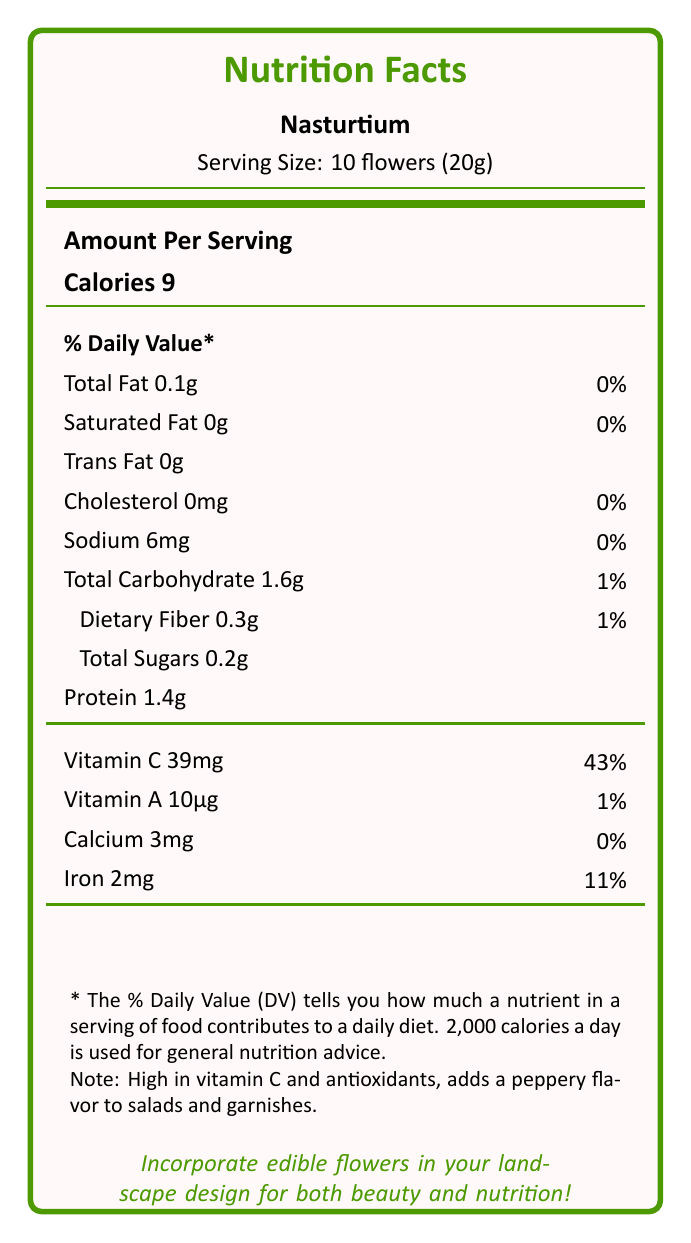what is the serving size for Nasturtium? The document specifies that the serving size for Nasturtium is 10 flowers, which weighs 20 grams.
Answer: 10 flowers (20g) how many calories are in a serving of Nasturtium? The document indicates that the amount of calories in a serving of Nasturtium is 9.
Answer: 9 calories how much vitamin C does a serving of Nasturtium provide? The document states that a serving of Nasturtium contains 39mg of vitamin C.
Answer: 39mg what percentage of the Daily Value (DV) does the vitamin C in Nasturtium serve? Based on the document, the vitamin C content in a serving of Nasturtium is 43% of the Daily Value.
Answer: 43% which nutrient contributes the most to the Daily Value percentage in a serving of Nasturtium? The document shows that vitamin C has the highest contribution to the Daily Value at 43%.
Answer: Vitamin C how much protein is in a serving of Nasturtium? The document specifies that there are 1.4 grams of protein in a serving of Nasturtium.
Answer: 1.4g what is the main flavor profile added by Nasturtium to salads and garnishes? The note in the document mentions that Nasturtium adds a peppery flavor to salads and garnishes.
Answer: Peppery does Nasturtium contain any trans fat? The document indicates that Nasturtium contains 0g of trans fat.
Answer: No what is the main idea of this document? The document mainly focuses on nutritional facts, Daily Value percentages, and notes about Nasturtium's culinary uses and flavors in landscape design.
Answer: The document provides comprehensive nutritional information for Nasturtium, highlighting its health benefits and culinary applications in landscape design. which other edible flower is suggested for use in salads and shares a low-calorie profile similar to Nasturtium? A. Lavender B. Borage C. Calendula D. Dandelion Based on the notes, Calendula is used in salads and has a low calorie count (1 calorie per serving), similar to Nasturtium (9 calories per serving).
Answer: C. Calendula which of the following nutrients does Nasturtium not provide a significant percentage of the Daily Value? I. Calcium II. Iron III. Vitamin A A. I only B. I and II C. III only D. I, II, and III The document indicates that Calcium (0%), Iron (11%), and Vitamin A (1%) all contribute relatively low percentages to the Daily Value when compared to other nutrients like Vitamin C.
Answer: D. I, II, and III does the document provide information on how Nasturtium can be used in culinary applications? The document specifically mentions in the notes that Nasturtium adds a peppery flavor to salads and garnishes, which indicates its use in culinary applications.
Answer: Yes how does the serving size of Nasturtium compare to that of other edible flowers like Lavender and Borage? The serving size for Nasturtium is 10 flowers (20g), which is larger compared to Lavender's 1 tablespoon (2g) and Borage's 5 flowers (10g).
Answer: Larger what are the antioxidant properties mentioned in the document? The notes section mentions that Nasturtium is high in vitamin C and antioxidants.
Answer: Antioxidants are noted to be high in the flower what essential oils are mentioned in the document? The document does not provide details about essential oils; it only mentions nutritional facts and specific uses for Nasturtium.
Answer: Not enough information 